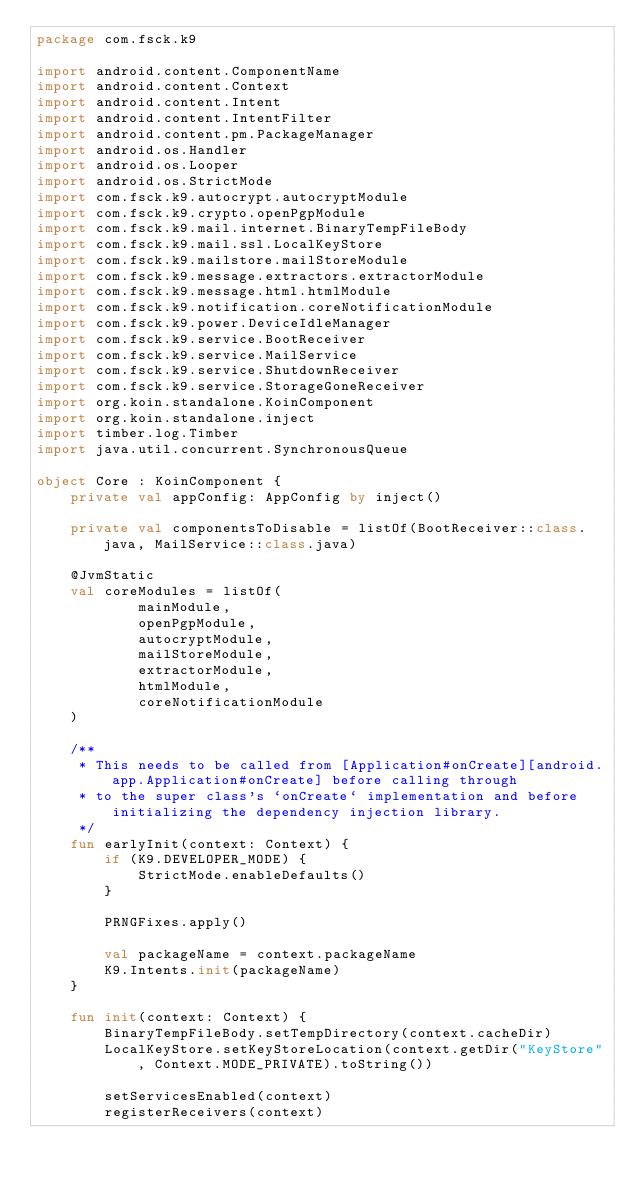<code> <loc_0><loc_0><loc_500><loc_500><_Kotlin_>package com.fsck.k9

import android.content.ComponentName
import android.content.Context
import android.content.Intent
import android.content.IntentFilter
import android.content.pm.PackageManager
import android.os.Handler
import android.os.Looper
import android.os.StrictMode
import com.fsck.k9.autocrypt.autocryptModule
import com.fsck.k9.crypto.openPgpModule
import com.fsck.k9.mail.internet.BinaryTempFileBody
import com.fsck.k9.mail.ssl.LocalKeyStore
import com.fsck.k9.mailstore.mailStoreModule
import com.fsck.k9.message.extractors.extractorModule
import com.fsck.k9.message.html.htmlModule
import com.fsck.k9.notification.coreNotificationModule
import com.fsck.k9.power.DeviceIdleManager
import com.fsck.k9.service.BootReceiver
import com.fsck.k9.service.MailService
import com.fsck.k9.service.ShutdownReceiver
import com.fsck.k9.service.StorageGoneReceiver
import org.koin.standalone.KoinComponent
import org.koin.standalone.inject
import timber.log.Timber
import java.util.concurrent.SynchronousQueue

object Core : KoinComponent {
    private val appConfig: AppConfig by inject()

    private val componentsToDisable = listOf(BootReceiver::class.java, MailService::class.java)

    @JvmStatic
    val coreModules = listOf(
            mainModule,
            openPgpModule,
            autocryptModule,
            mailStoreModule,
            extractorModule,
            htmlModule,
            coreNotificationModule
    )

    /**
     * This needs to be called from [Application#onCreate][android.app.Application#onCreate] before calling through
     * to the super class's `onCreate` implementation and before initializing the dependency injection library.
     */
    fun earlyInit(context: Context) {
        if (K9.DEVELOPER_MODE) {
            StrictMode.enableDefaults()
        }

        PRNGFixes.apply()

        val packageName = context.packageName
        K9.Intents.init(packageName)
    }

    fun init(context: Context) {
        BinaryTempFileBody.setTempDirectory(context.cacheDir)
        LocalKeyStore.setKeyStoreLocation(context.getDir("KeyStore", Context.MODE_PRIVATE).toString())

        setServicesEnabled(context)
        registerReceivers(context)</code> 